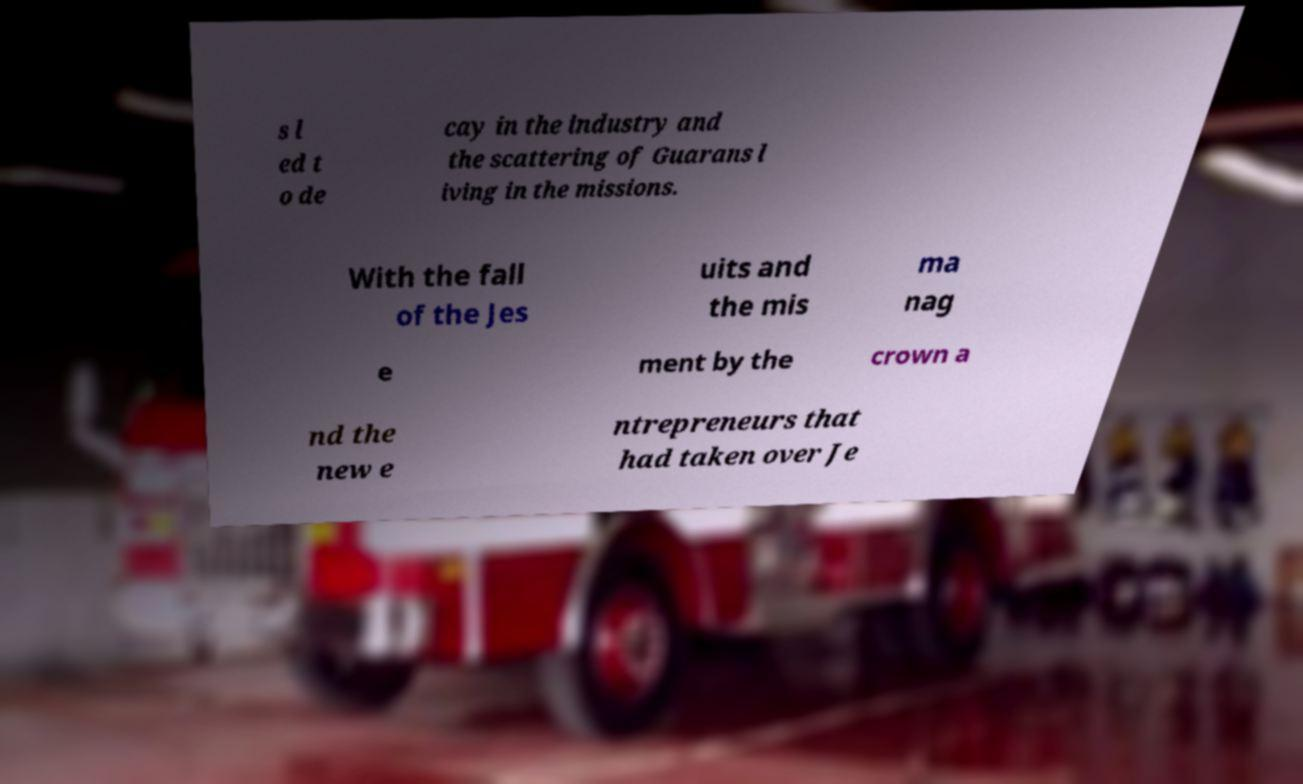For documentation purposes, I need the text within this image transcribed. Could you provide that? s l ed t o de cay in the industry and the scattering of Guarans l iving in the missions. With the fall of the Jes uits and the mis ma nag e ment by the crown a nd the new e ntrepreneurs that had taken over Je 